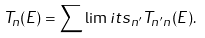Convert formula to latex. <formula><loc_0><loc_0><loc_500><loc_500>T _ { n } ( E ) = \sum \lim i t s _ { n ^ { \prime } } T _ { n ^ { \prime } n } ( E ) .</formula> 